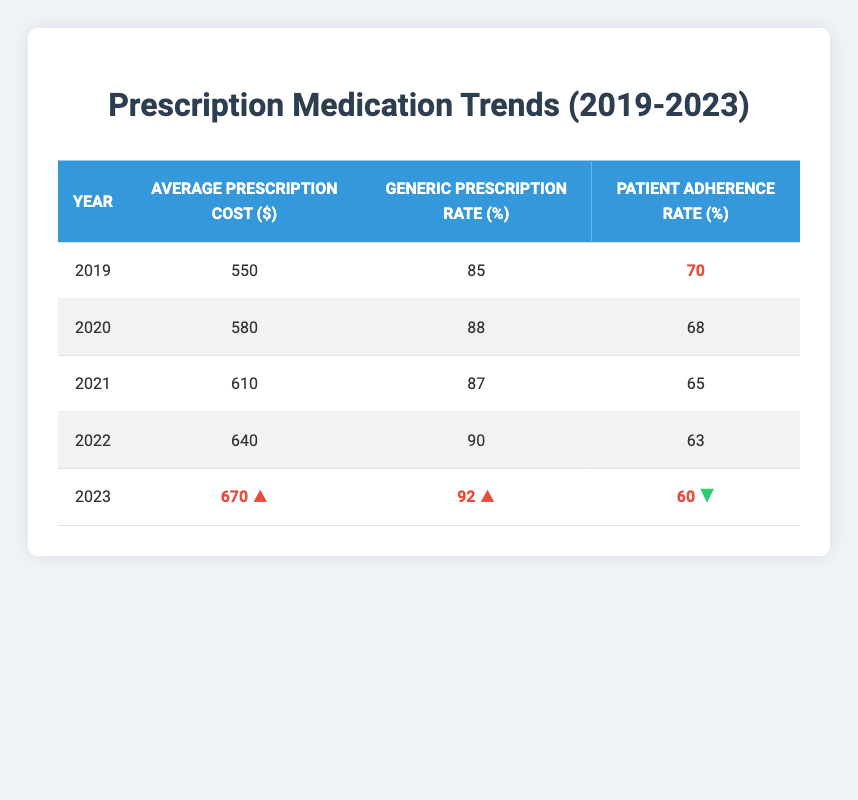What was the average prescription cost in 2022? Referring to the table, the value in the "Average Prescription Cost ($)" column for the year 2022 is 640.
Answer: 640 What is the patient adherence rate in 2020? Looking at the table, the "Patient Adherence Rate (%)" for the year 2020 is 68.
Answer: 68 In which year did the generic prescription rate first exceed 90%? The generic prescription rate first exceeded 90% in 2022, as seen in the "Generic Prescription Rate (%)" column for that year, which is 90.
Answer: 2022 How much did the average prescription cost increase from 2019 to 2023? The average prescription cost in 2019 was 550 and in 2023 it is 670, so the increase is 670 - 550 = 120.
Answer: 120 What is the average patient adherence rate over the last five years? To find the average adherence rate, sum the rates (70 + 68 + 65 + 63 + 60 = 326) and divide by the number of years (326 / 5 = 65.2). The average patient adherence rate over the last five years is approximately 65.2.
Answer: 65.2 Is the patient adherence rate increasing or decreasing from 2019 to 2023? The patient adherence rate has decreased from 70 in 2019 to 60 in 2023, indicating a decline.
Answer: Decreasing What was the generic prescription rate in the year with the lowest patient adherence rate? The year with the lowest patient adherence rate is 2023 (60%). In that same year, the generic prescription rate is 92%.
Answer: 92 Which year shows the highest average prescription cost? The highest average prescription cost is in 2023, with a value of 670, as indicated in the "Average Prescription Cost ($)" column.
Answer: 2023 What percentage of prescriptions were generic in 2021? In 2021, the table shows that the "Generic Prescription Rate (%)" is 87.
Answer: 87 Was the average prescription cost consistently increasing each year? Yes, the average prescription cost increased each year from 2019 (550) to 2023 (670), showing a consistent trend in the data.
Answer: Yes What is the difference in generic prescription rates between 2019 and 2023? The generic prescription rate in 2019 was 85% and in 2023 it is 92%, resulting in a difference of 92 - 85 = 7.
Answer: 7 